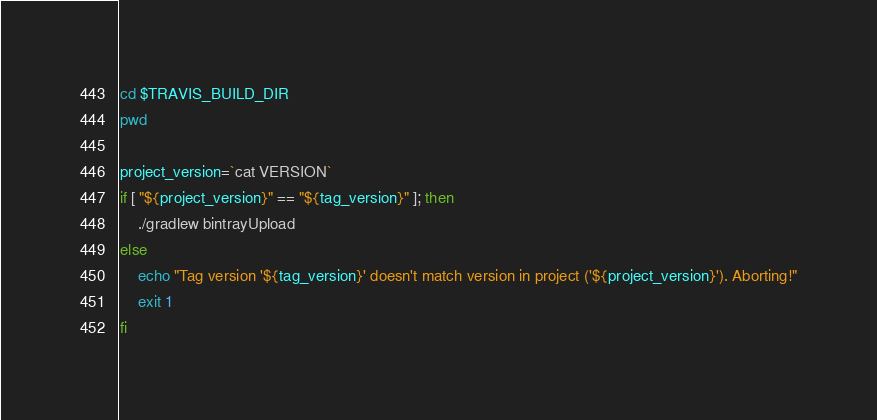<code> <loc_0><loc_0><loc_500><loc_500><_Bash_>cd $TRAVIS_BUILD_DIR
pwd

project_version=`cat VERSION`
if [ "${project_version}" == "${tag_version}" ]; then
    ./gradlew bintrayUpload
else
    echo "Tag version '${tag_version}' doesn't match version in project ('${project_version}'). Aborting!"
    exit 1
fi
</code> 